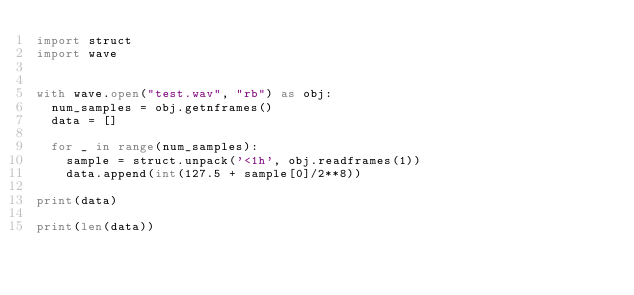<code> <loc_0><loc_0><loc_500><loc_500><_Python_>import struct
import wave


with wave.open("test.wav", "rb") as obj:
  num_samples = obj.getnframes()
  data = []

  for _ in range(num_samples):
    sample = struct.unpack('<1h', obj.readframes(1))
    data.append(int(127.5 + sample[0]/2**8))

print(data)

print(len(data))
</code> 